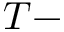Convert formula to latex. <formula><loc_0><loc_0><loc_500><loc_500>T -</formula> 